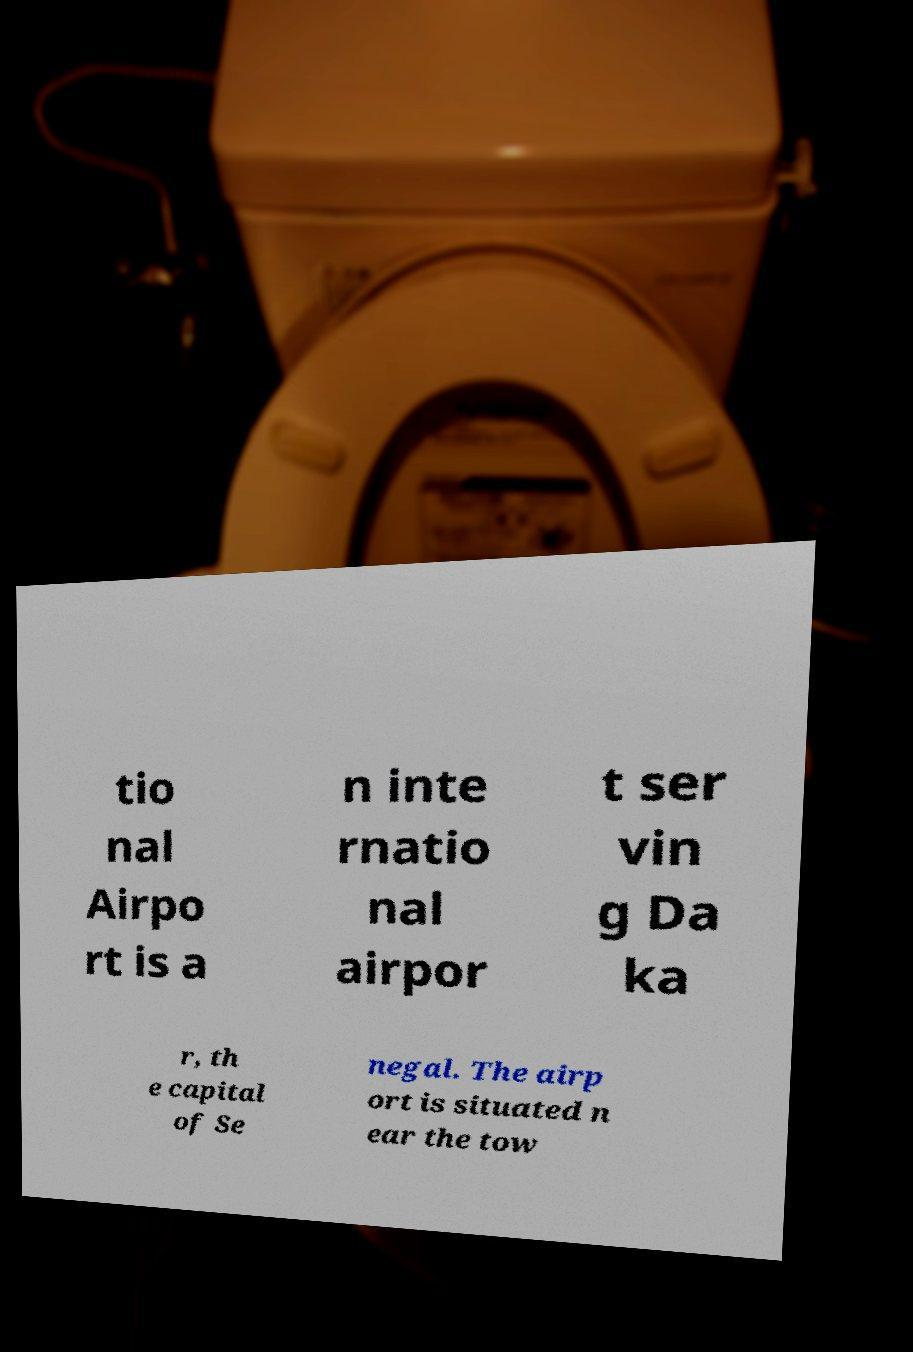Could you extract and type out the text from this image? tio nal Airpo rt is a n inte rnatio nal airpor t ser vin g Da ka r, th e capital of Se negal. The airp ort is situated n ear the tow 